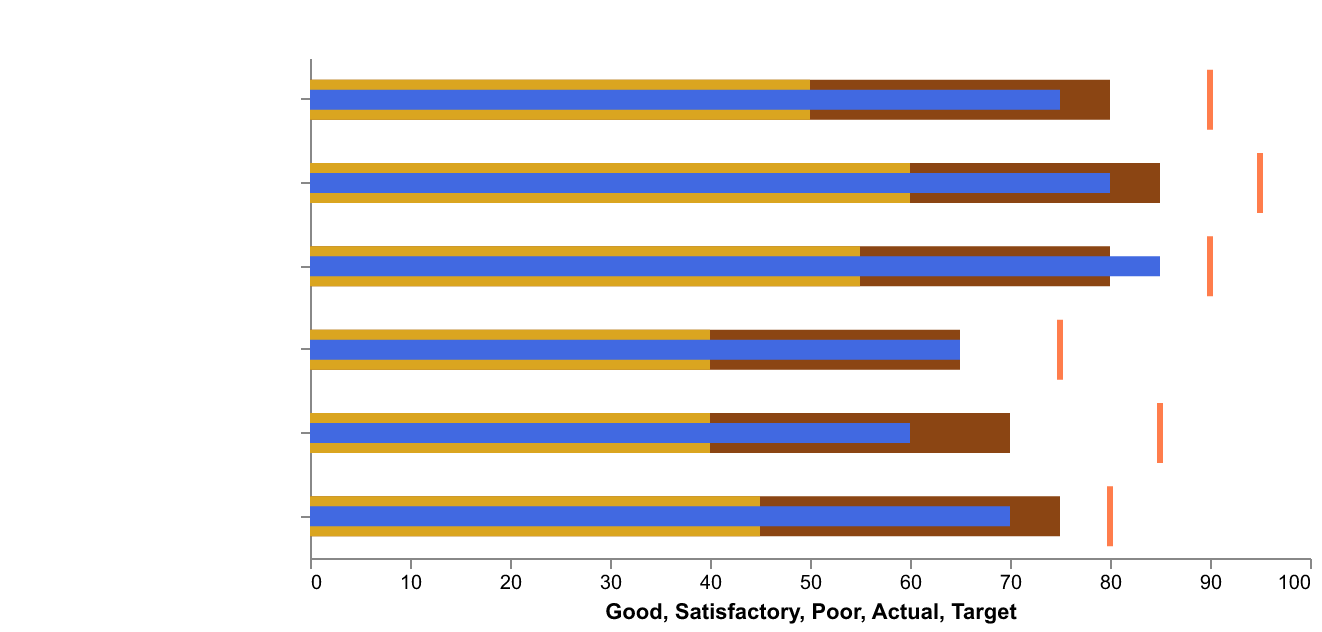What's the title of the chart? The title can be seen at the top of the chart. It reads "Minecraft Skill Development."
Answer: Minecraft Skill Development What's the achieved score for Building Skills? The score for achieved performance is shown using a blue bar for each skill category. The blue bar for Building Skills corresponds to a value of 75.
Answer: 75 Which skill has the highest target value? To find the highest target value, look at the red ticks along the x-axis for each skill. Combat Proficiency has the highest target at 95.
Answer: Combat Proficiency What is the difference between the Actual score and Target score for Redstone Engineering? The Actual score (blue bar) is 60 and the Target score (red tick) is 85. The difference is 85 - 60 = 25.
Answer: 25 Which skill exceeds the Good level? Compare Actual scores (blue bars) against Good levels (brown bars). Exploration Expertise (85) exceeds its Good level (80).
Answer: Exploration Expertise Which skills fall below their Satisfactory level? Compare Actual scores (blue bars) against Satisfactory levels (gold bars). Redstone Engineering (60) and Mob Knowledge (65) fall below their Satisfactory levels of 70 and 75 respectively.
Answer: Redstone Engineering, Mob Knowledge What is the average Actual score across all skills? Sum the Actual scores (75 + 60 + 80 + 70 + 85 + 65) = 435 and divide by the number of skills (6), which gives 435/6 ≈ 72.5.
Answer: 72.5 Which skill has the smallest gap between its Actual and Target scores? Calculate the differences for each skill: Building Skills (15), Redstone Engineering (25), Combat Proficiency (15), Resource Management (10), Exploration Expertise (5), Mob Knowledge (10). The smallest is Exploration Expertise (5).
Answer: Exploration Expertise Based on the figure, what can you infer about the player's strongest skill? Look at the Actual scores and compare them; Exploration Expertise has the highest Actual score (85), indicating it as the player’s strongest skill.
Answer: Exploration Expertise Which skill's Actual score is closest to its Satisfactory level? Find the difference between Actual and Satisfactory for each skill: Building Skills (25), Redstone Engineering (20), Combat Proficiency (20), Resource Management (25), Exploration Expertise (30), Mob Knowledge (25). The smallest difference is for Redstone Engineering and Combat Proficiency (both 20).
Answer: Redstone Engineering, Combat Proficiency 